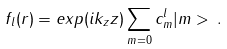<formula> <loc_0><loc_0><loc_500><loc_500>f _ { l } ( r ) = e x p ( i k _ { z } z ) \sum _ { m = 0 } c ^ { l } _ { m } | m > \, .</formula> 